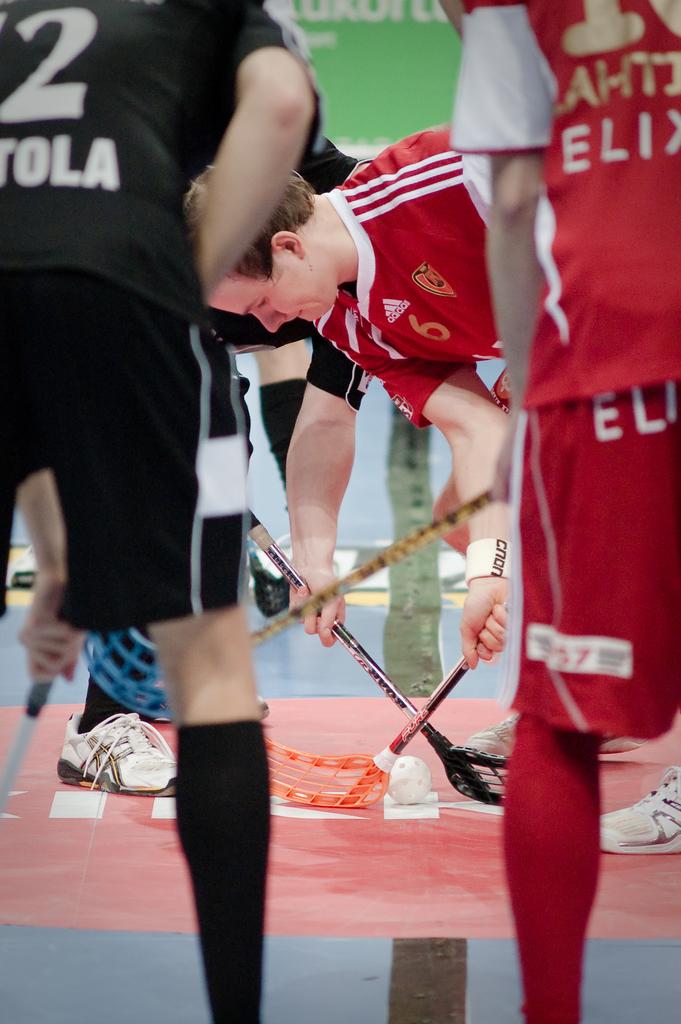What is the text written on the back of the shirts?
Provide a short and direct response. Unanswerable. What is the brand name on the red jersey that made them?
Offer a terse response. Unanswerable. 